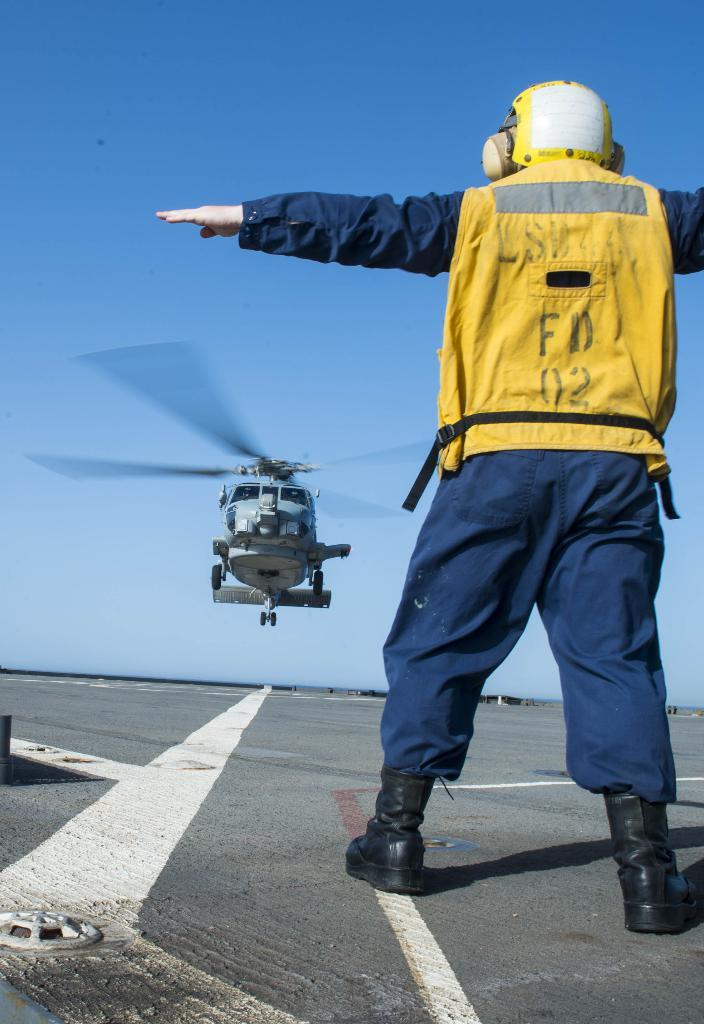What is happening in the foreground of the image? There is a person standing on the road in the foreground. What can be seen in the background of the image? There is an aircraft in the background. What color is the sky in the image? The sky is blue in the image. When was the image taken? The image was taken during the day. What type of battle is taking place in the image? There is no battle present in the image; it features a person standing on the road and an aircraft in the background. What material is the silk used for in the image? There is no silk present in the image. 